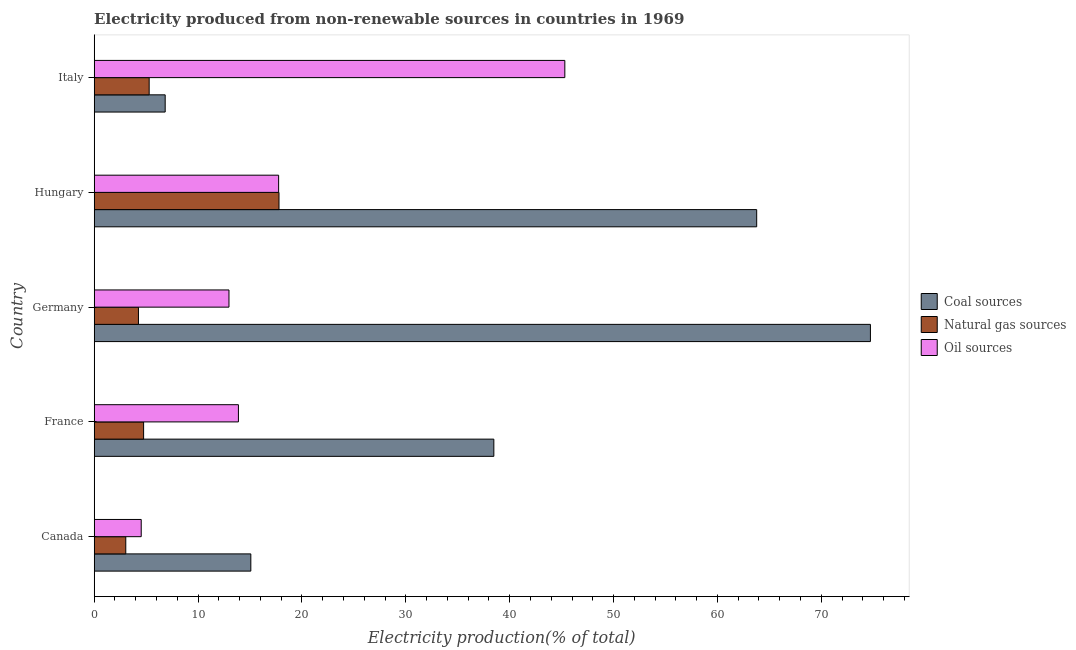How many different coloured bars are there?
Ensure brevity in your answer.  3. How many groups of bars are there?
Provide a succinct answer. 5. How many bars are there on the 2nd tick from the top?
Provide a succinct answer. 3. What is the percentage of electricity produced by natural gas in Canada?
Your answer should be compact. 3.04. Across all countries, what is the maximum percentage of electricity produced by coal?
Keep it short and to the point. 74.73. Across all countries, what is the minimum percentage of electricity produced by natural gas?
Give a very brief answer. 3.04. In which country was the percentage of electricity produced by coal minimum?
Ensure brevity in your answer.  Italy. What is the total percentage of electricity produced by natural gas in the graph?
Keep it short and to the point. 35.14. What is the difference between the percentage of electricity produced by coal in France and that in Italy?
Your answer should be very brief. 31.64. What is the difference between the percentage of electricity produced by oil sources in Canada and the percentage of electricity produced by coal in Germany?
Provide a succinct answer. -70.2. What is the average percentage of electricity produced by coal per country?
Keep it short and to the point. 39.78. What is the difference between the percentage of electricity produced by oil sources and percentage of electricity produced by coal in Canada?
Your answer should be compact. -10.55. In how many countries, is the percentage of electricity produced by oil sources greater than 24 %?
Keep it short and to the point. 1. What is the ratio of the percentage of electricity produced by coal in Canada to that in France?
Your response must be concise. 0.39. Is the percentage of electricity produced by coal in France less than that in Italy?
Give a very brief answer. No. Is the difference between the percentage of electricity produced by natural gas in Canada and Italy greater than the difference between the percentage of electricity produced by oil sources in Canada and Italy?
Keep it short and to the point. Yes. What is the difference between the highest and the second highest percentage of electricity produced by natural gas?
Provide a short and direct response. 12.5. What is the difference between the highest and the lowest percentage of electricity produced by oil sources?
Ensure brevity in your answer.  40.78. In how many countries, is the percentage of electricity produced by natural gas greater than the average percentage of electricity produced by natural gas taken over all countries?
Keep it short and to the point. 1. What does the 3rd bar from the top in Hungary represents?
Provide a succinct answer. Coal sources. What does the 3rd bar from the bottom in Canada represents?
Make the answer very short. Oil sources. How many bars are there?
Ensure brevity in your answer.  15. Are all the bars in the graph horizontal?
Give a very brief answer. Yes. How many countries are there in the graph?
Provide a short and direct response. 5. Are the values on the major ticks of X-axis written in scientific E-notation?
Your response must be concise. No. Does the graph contain grids?
Ensure brevity in your answer.  No. How many legend labels are there?
Keep it short and to the point. 3. What is the title of the graph?
Make the answer very short. Electricity produced from non-renewable sources in countries in 1969. Does "Services" appear as one of the legend labels in the graph?
Your response must be concise. No. What is the label or title of the Y-axis?
Offer a very short reply. Country. What is the Electricity production(% of total) of Coal sources in Canada?
Make the answer very short. 15.08. What is the Electricity production(% of total) in Natural gas sources in Canada?
Provide a succinct answer. 3.04. What is the Electricity production(% of total) of Oil sources in Canada?
Offer a very short reply. 4.53. What is the Electricity production(% of total) of Coal sources in France?
Your answer should be very brief. 38.47. What is the Electricity production(% of total) of Natural gas sources in France?
Provide a short and direct response. 4.76. What is the Electricity production(% of total) of Oil sources in France?
Your answer should be very brief. 13.88. What is the Electricity production(% of total) of Coal sources in Germany?
Provide a succinct answer. 74.73. What is the Electricity production(% of total) of Natural gas sources in Germany?
Make the answer very short. 4.26. What is the Electricity production(% of total) in Oil sources in Germany?
Provide a short and direct response. 12.97. What is the Electricity production(% of total) in Coal sources in Hungary?
Your answer should be very brief. 63.78. What is the Electricity production(% of total) of Natural gas sources in Hungary?
Offer a terse response. 17.79. What is the Electricity production(% of total) of Oil sources in Hungary?
Make the answer very short. 17.76. What is the Electricity production(% of total) in Coal sources in Italy?
Provide a succinct answer. 6.83. What is the Electricity production(% of total) of Natural gas sources in Italy?
Your answer should be very brief. 5.29. What is the Electricity production(% of total) in Oil sources in Italy?
Your response must be concise. 45.31. Across all countries, what is the maximum Electricity production(% of total) in Coal sources?
Provide a succinct answer. 74.73. Across all countries, what is the maximum Electricity production(% of total) of Natural gas sources?
Give a very brief answer. 17.79. Across all countries, what is the maximum Electricity production(% of total) of Oil sources?
Offer a terse response. 45.31. Across all countries, what is the minimum Electricity production(% of total) in Coal sources?
Offer a very short reply. 6.83. Across all countries, what is the minimum Electricity production(% of total) of Natural gas sources?
Your answer should be compact. 3.04. Across all countries, what is the minimum Electricity production(% of total) of Oil sources?
Provide a succinct answer. 4.53. What is the total Electricity production(% of total) of Coal sources in the graph?
Offer a very short reply. 198.89. What is the total Electricity production(% of total) in Natural gas sources in the graph?
Ensure brevity in your answer.  35.14. What is the total Electricity production(% of total) in Oil sources in the graph?
Give a very brief answer. 94.45. What is the difference between the Electricity production(% of total) of Coal sources in Canada and that in France?
Your response must be concise. -23.4. What is the difference between the Electricity production(% of total) in Natural gas sources in Canada and that in France?
Offer a very short reply. -1.72. What is the difference between the Electricity production(% of total) of Oil sources in Canada and that in France?
Keep it short and to the point. -9.36. What is the difference between the Electricity production(% of total) of Coal sources in Canada and that in Germany?
Make the answer very short. -59.65. What is the difference between the Electricity production(% of total) of Natural gas sources in Canada and that in Germany?
Offer a terse response. -1.22. What is the difference between the Electricity production(% of total) in Oil sources in Canada and that in Germany?
Your response must be concise. -8.45. What is the difference between the Electricity production(% of total) of Coal sources in Canada and that in Hungary?
Your response must be concise. -48.7. What is the difference between the Electricity production(% of total) of Natural gas sources in Canada and that in Hungary?
Provide a succinct answer. -14.75. What is the difference between the Electricity production(% of total) of Oil sources in Canada and that in Hungary?
Provide a short and direct response. -13.23. What is the difference between the Electricity production(% of total) in Coal sources in Canada and that in Italy?
Your answer should be very brief. 8.24. What is the difference between the Electricity production(% of total) in Natural gas sources in Canada and that in Italy?
Your answer should be very brief. -2.25. What is the difference between the Electricity production(% of total) of Oil sources in Canada and that in Italy?
Keep it short and to the point. -40.78. What is the difference between the Electricity production(% of total) in Coal sources in France and that in Germany?
Give a very brief answer. -36.25. What is the difference between the Electricity production(% of total) in Natural gas sources in France and that in Germany?
Your answer should be compact. 0.5. What is the difference between the Electricity production(% of total) in Oil sources in France and that in Germany?
Provide a succinct answer. 0.91. What is the difference between the Electricity production(% of total) in Coal sources in France and that in Hungary?
Provide a short and direct response. -25.3. What is the difference between the Electricity production(% of total) in Natural gas sources in France and that in Hungary?
Keep it short and to the point. -13.03. What is the difference between the Electricity production(% of total) of Oil sources in France and that in Hungary?
Your answer should be very brief. -3.87. What is the difference between the Electricity production(% of total) of Coal sources in France and that in Italy?
Your answer should be compact. 31.64. What is the difference between the Electricity production(% of total) of Natural gas sources in France and that in Italy?
Your response must be concise. -0.54. What is the difference between the Electricity production(% of total) in Oil sources in France and that in Italy?
Provide a succinct answer. -31.42. What is the difference between the Electricity production(% of total) in Coal sources in Germany and that in Hungary?
Your response must be concise. 10.95. What is the difference between the Electricity production(% of total) of Natural gas sources in Germany and that in Hungary?
Offer a terse response. -13.53. What is the difference between the Electricity production(% of total) of Oil sources in Germany and that in Hungary?
Provide a short and direct response. -4.78. What is the difference between the Electricity production(% of total) in Coal sources in Germany and that in Italy?
Ensure brevity in your answer.  67.89. What is the difference between the Electricity production(% of total) in Natural gas sources in Germany and that in Italy?
Provide a short and direct response. -1.03. What is the difference between the Electricity production(% of total) in Oil sources in Germany and that in Italy?
Your answer should be compact. -32.33. What is the difference between the Electricity production(% of total) of Coal sources in Hungary and that in Italy?
Offer a terse response. 56.94. What is the difference between the Electricity production(% of total) in Natural gas sources in Hungary and that in Italy?
Provide a short and direct response. 12.5. What is the difference between the Electricity production(% of total) in Oil sources in Hungary and that in Italy?
Your response must be concise. -27.55. What is the difference between the Electricity production(% of total) in Coal sources in Canada and the Electricity production(% of total) in Natural gas sources in France?
Your response must be concise. 10.32. What is the difference between the Electricity production(% of total) of Coal sources in Canada and the Electricity production(% of total) of Oil sources in France?
Provide a succinct answer. 1.19. What is the difference between the Electricity production(% of total) of Natural gas sources in Canada and the Electricity production(% of total) of Oil sources in France?
Your response must be concise. -10.84. What is the difference between the Electricity production(% of total) of Coal sources in Canada and the Electricity production(% of total) of Natural gas sources in Germany?
Your answer should be compact. 10.82. What is the difference between the Electricity production(% of total) of Coal sources in Canada and the Electricity production(% of total) of Oil sources in Germany?
Your answer should be very brief. 2.1. What is the difference between the Electricity production(% of total) in Natural gas sources in Canada and the Electricity production(% of total) in Oil sources in Germany?
Keep it short and to the point. -9.93. What is the difference between the Electricity production(% of total) of Coal sources in Canada and the Electricity production(% of total) of Natural gas sources in Hungary?
Your answer should be very brief. -2.71. What is the difference between the Electricity production(% of total) in Coal sources in Canada and the Electricity production(% of total) in Oil sources in Hungary?
Your answer should be compact. -2.68. What is the difference between the Electricity production(% of total) of Natural gas sources in Canada and the Electricity production(% of total) of Oil sources in Hungary?
Keep it short and to the point. -14.71. What is the difference between the Electricity production(% of total) of Coal sources in Canada and the Electricity production(% of total) of Natural gas sources in Italy?
Offer a very short reply. 9.79. What is the difference between the Electricity production(% of total) of Coal sources in Canada and the Electricity production(% of total) of Oil sources in Italy?
Ensure brevity in your answer.  -30.23. What is the difference between the Electricity production(% of total) in Natural gas sources in Canada and the Electricity production(% of total) in Oil sources in Italy?
Provide a short and direct response. -42.27. What is the difference between the Electricity production(% of total) of Coal sources in France and the Electricity production(% of total) of Natural gas sources in Germany?
Ensure brevity in your answer.  34.21. What is the difference between the Electricity production(% of total) of Coal sources in France and the Electricity production(% of total) of Oil sources in Germany?
Offer a very short reply. 25.5. What is the difference between the Electricity production(% of total) in Natural gas sources in France and the Electricity production(% of total) in Oil sources in Germany?
Your answer should be compact. -8.22. What is the difference between the Electricity production(% of total) in Coal sources in France and the Electricity production(% of total) in Natural gas sources in Hungary?
Offer a very short reply. 20.68. What is the difference between the Electricity production(% of total) in Coal sources in France and the Electricity production(% of total) in Oil sources in Hungary?
Offer a terse response. 20.72. What is the difference between the Electricity production(% of total) in Natural gas sources in France and the Electricity production(% of total) in Oil sources in Hungary?
Give a very brief answer. -13. What is the difference between the Electricity production(% of total) in Coal sources in France and the Electricity production(% of total) in Natural gas sources in Italy?
Keep it short and to the point. 33.18. What is the difference between the Electricity production(% of total) in Coal sources in France and the Electricity production(% of total) in Oil sources in Italy?
Make the answer very short. -6.83. What is the difference between the Electricity production(% of total) in Natural gas sources in France and the Electricity production(% of total) in Oil sources in Italy?
Your answer should be very brief. -40.55. What is the difference between the Electricity production(% of total) of Coal sources in Germany and the Electricity production(% of total) of Natural gas sources in Hungary?
Your response must be concise. 56.94. What is the difference between the Electricity production(% of total) in Coal sources in Germany and the Electricity production(% of total) in Oil sources in Hungary?
Provide a succinct answer. 56.97. What is the difference between the Electricity production(% of total) of Natural gas sources in Germany and the Electricity production(% of total) of Oil sources in Hungary?
Provide a short and direct response. -13.49. What is the difference between the Electricity production(% of total) of Coal sources in Germany and the Electricity production(% of total) of Natural gas sources in Italy?
Provide a short and direct response. 69.43. What is the difference between the Electricity production(% of total) of Coal sources in Germany and the Electricity production(% of total) of Oil sources in Italy?
Keep it short and to the point. 29.42. What is the difference between the Electricity production(% of total) of Natural gas sources in Germany and the Electricity production(% of total) of Oil sources in Italy?
Offer a very short reply. -41.05. What is the difference between the Electricity production(% of total) of Coal sources in Hungary and the Electricity production(% of total) of Natural gas sources in Italy?
Offer a terse response. 58.49. What is the difference between the Electricity production(% of total) of Coal sources in Hungary and the Electricity production(% of total) of Oil sources in Italy?
Keep it short and to the point. 18.47. What is the difference between the Electricity production(% of total) in Natural gas sources in Hungary and the Electricity production(% of total) in Oil sources in Italy?
Your answer should be compact. -27.52. What is the average Electricity production(% of total) in Coal sources per country?
Provide a short and direct response. 39.78. What is the average Electricity production(% of total) in Natural gas sources per country?
Offer a very short reply. 7.03. What is the average Electricity production(% of total) in Oil sources per country?
Keep it short and to the point. 18.89. What is the difference between the Electricity production(% of total) in Coal sources and Electricity production(% of total) in Natural gas sources in Canada?
Offer a very short reply. 12.04. What is the difference between the Electricity production(% of total) in Coal sources and Electricity production(% of total) in Oil sources in Canada?
Your response must be concise. 10.55. What is the difference between the Electricity production(% of total) of Natural gas sources and Electricity production(% of total) of Oil sources in Canada?
Your response must be concise. -1.49. What is the difference between the Electricity production(% of total) of Coal sources and Electricity production(% of total) of Natural gas sources in France?
Ensure brevity in your answer.  33.72. What is the difference between the Electricity production(% of total) of Coal sources and Electricity production(% of total) of Oil sources in France?
Your answer should be compact. 24.59. What is the difference between the Electricity production(% of total) of Natural gas sources and Electricity production(% of total) of Oil sources in France?
Offer a terse response. -9.13. What is the difference between the Electricity production(% of total) in Coal sources and Electricity production(% of total) in Natural gas sources in Germany?
Provide a succinct answer. 70.47. What is the difference between the Electricity production(% of total) in Coal sources and Electricity production(% of total) in Oil sources in Germany?
Your answer should be compact. 61.75. What is the difference between the Electricity production(% of total) in Natural gas sources and Electricity production(% of total) in Oil sources in Germany?
Ensure brevity in your answer.  -8.71. What is the difference between the Electricity production(% of total) of Coal sources and Electricity production(% of total) of Natural gas sources in Hungary?
Make the answer very short. 45.99. What is the difference between the Electricity production(% of total) of Coal sources and Electricity production(% of total) of Oil sources in Hungary?
Provide a succinct answer. 46.02. What is the difference between the Electricity production(% of total) of Natural gas sources and Electricity production(% of total) of Oil sources in Hungary?
Your response must be concise. 0.04. What is the difference between the Electricity production(% of total) of Coal sources and Electricity production(% of total) of Natural gas sources in Italy?
Keep it short and to the point. 1.54. What is the difference between the Electricity production(% of total) in Coal sources and Electricity production(% of total) in Oil sources in Italy?
Keep it short and to the point. -38.47. What is the difference between the Electricity production(% of total) in Natural gas sources and Electricity production(% of total) in Oil sources in Italy?
Your answer should be compact. -40.02. What is the ratio of the Electricity production(% of total) of Coal sources in Canada to that in France?
Your answer should be very brief. 0.39. What is the ratio of the Electricity production(% of total) in Natural gas sources in Canada to that in France?
Your response must be concise. 0.64. What is the ratio of the Electricity production(% of total) in Oil sources in Canada to that in France?
Your answer should be compact. 0.33. What is the ratio of the Electricity production(% of total) in Coal sources in Canada to that in Germany?
Your answer should be compact. 0.2. What is the ratio of the Electricity production(% of total) of Natural gas sources in Canada to that in Germany?
Your response must be concise. 0.71. What is the ratio of the Electricity production(% of total) in Oil sources in Canada to that in Germany?
Offer a very short reply. 0.35. What is the ratio of the Electricity production(% of total) of Coal sources in Canada to that in Hungary?
Keep it short and to the point. 0.24. What is the ratio of the Electricity production(% of total) of Natural gas sources in Canada to that in Hungary?
Offer a very short reply. 0.17. What is the ratio of the Electricity production(% of total) of Oil sources in Canada to that in Hungary?
Give a very brief answer. 0.26. What is the ratio of the Electricity production(% of total) of Coal sources in Canada to that in Italy?
Your answer should be compact. 2.21. What is the ratio of the Electricity production(% of total) in Natural gas sources in Canada to that in Italy?
Your response must be concise. 0.57. What is the ratio of the Electricity production(% of total) in Oil sources in Canada to that in Italy?
Keep it short and to the point. 0.1. What is the ratio of the Electricity production(% of total) of Coal sources in France to that in Germany?
Keep it short and to the point. 0.51. What is the ratio of the Electricity production(% of total) in Natural gas sources in France to that in Germany?
Give a very brief answer. 1.12. What is the ratio of the Electricity production(% of total) in Oil sources in France to that in Germany?
Offer a very short reply. 1.07. What is the ratio of the Electricity production(% of total) in Coal sources in France to that in Hungary?
Make the answer very short. 0.6. What is the ratio of the Electricity production(% of total) of Natural gas sources in France to that in Hungary?
Offer a terse response. 0.27. What is the ratio of the Electricity production(% of total) of Oil sources in France to that in Hungary?
Keep it short and to the point. 0.78. What is the ratio of the Electricity production(% of total) in Coal sources in France to that in Italy?
Your response must be concise. 5.63. What is the ratio of the Electricity production(% of total) of Natural gas sources in France to that in Italy?
Keep it short and to the point. 0.9. What is the ratio of the Electricity production(% of total) of Oil sources in France to that in Italy?
Your answer should be compact. 0.31. What is the ratio of the Electricity production(% of total) of Coal sources in Germany to that in Hungary?
Your answer should be very brief. 1.17. What is the ratio of the Electricity production(% of total) in Natural gas sources in Germany to that in Hungary?
Your answer should be compact. 0.24. What is the ratio of the Electricity production(% of total) in Oil sources in Germany to that in Hungary?
Ensure brevity in your answer.  0.73. What is the ratio of the Electricity production(% of total) in Coal sources in Germany to that in Italy?
Your response must be concise. 10.93. What is the ratio of the Electricity production(% of total) in Natural gas sources in Germany to that in Italy?
Keep it short and to the point. 0.81. What is the ratio of the Electricity production(% of total) in Oil sources in Germany to that in Italy?
Your response must be concise. 0.29. What is the ratio of the Electricity production(% of total) of Coal sources in Hungary to that in Italy?
Offer a very short reply. 9.33. What is the ratio of the Electricity production(% of total) of Natural gas sources in Hungary to that in Italy?
Provide a succinct answer. 3.36. What is the ratio of the Electricity production(% of total) of Oil sources in Hungary to that in Italy?
Your answer should be compact. 0.39. What is the difference between the highest and the second highest Electricity production(% of total) of Coal sources?
Provide a succinct answer. 10.95. What is the difference between the highest and the second highest Electricity production(% of total) of Natural gas sources?
Provide a succinct answer. 12.5. What is the difference between the highest and the second highest Electricity production(% of total) in Oil sources?
Provide a short and direct response. 27.55. What is the difference between the highest and the lowest Electricity production(% of total) in Coal sources?
Your response must be concise. 67.89. What is the difference between the highest and the lowest Electricity production(% of total) in Natural gas sources?
Keep it short and to the point. 14.75. What is the difference between the highest and the lowest Electricity production(% of total) in Oil sources?
Your response must be concise. 40.78. 